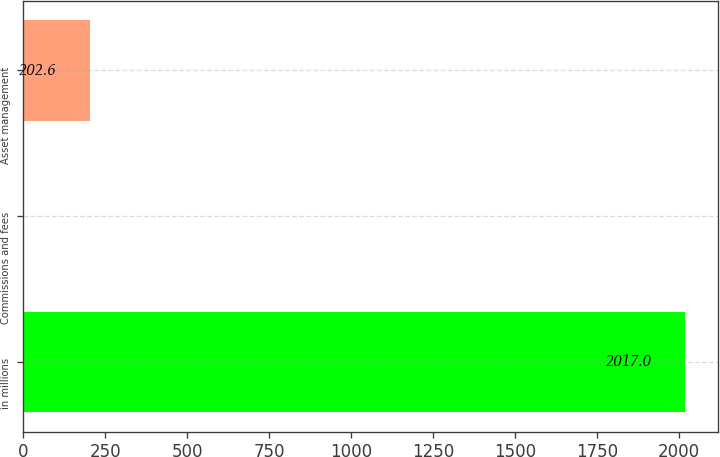Convert chart. <chart><loc_0><loc_0><loc_500><loc_500><bar_chart><fcel>in millions<fcel>Commissions and fees<fcel>Asset management<nl><fcel>2017<fcel>1<fcel>202.6<nl></chart> 